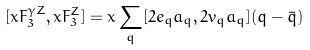<formula> <loc_0><loc_0><loc_500><loc_500>[ x F _ { 3 } ^ { \gamma Z } , x F _ { 3 } ^ { Z } ] = x \sum _ { q } [ 2 e _ { q } a _ { q } , 2 v _ { q } a _ { q } ] ( q - \bar { q } )</formula> 